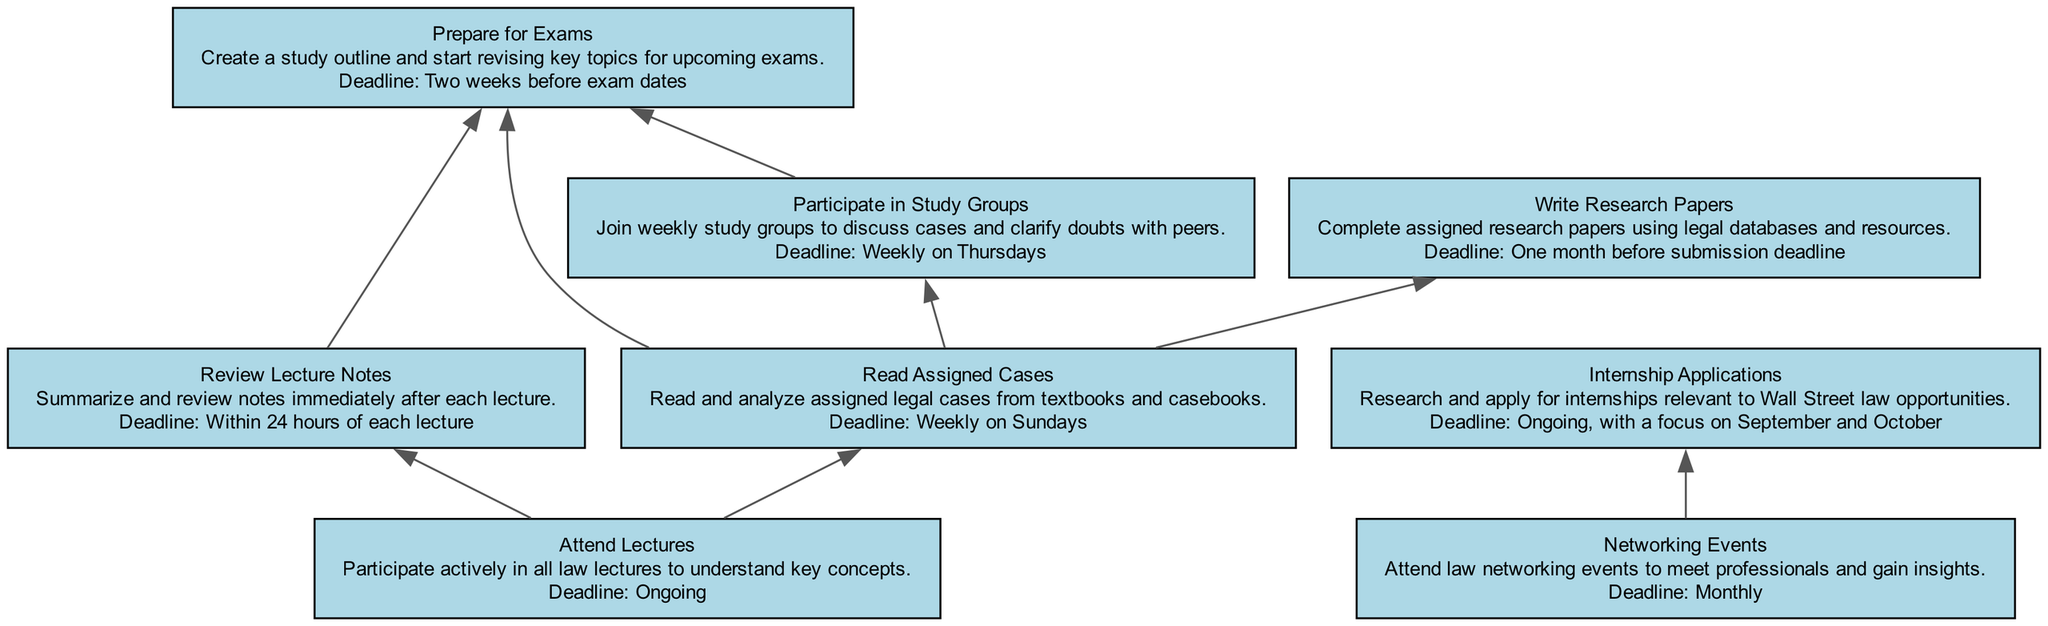What task is ongoing? The task that is ongoing is "Internship Applications" as indicated in the diagram. It is connected to networking events, reflecting its continuous nature in relation to other tasks.
Answer: Internship Applications How many nodes are present in the diagram? To find the total number of nodes, we count the tasks listed: Attend Lectures, Review Lecture Notes, Read Assigned Cases, Prepare for Exams, Participate in Study Groups, Write Research Papers, Internship Applications, and Networking Events. This totals up to 8 nodes.
Answer: 8 Which task needs to be completed within 24 hours? The task that needs to be completed within 24 hours is "Review Lecture Notes" as described in the diagram's details. It is specifically time-sensitive, asking for immediate action after lectures.
Answer: Review Lecture Notes Which task connects both the "Read Assigned Cases" and "Prepare for Exams"? The task that connects "Read Assigned Cases" to "Prepare for Exams" is "Participate in Study Groups." The diagram shows that insights drawn from study groups help in preparing for exams, creating a flow from assigned reading to exam preparation.
Answer: Participate in Study Groups How often are networking events scheduled? Networking events are scheduled monthly, as indicated in the task's deadline section on the diagram. This indicates regular participation opportunities to build professional connections.
Answer: Monthly What is the deadline for writing research papers? The deadline for writing research papers is specified as "One month before submission deadline" in the diagram. This means students need to allocate sufficient time to research and write prior to due dates.
Answer: One month before submission deadline What is the relationship between "Attend Lectures" and "Review Lecture Notes"? The relationship is that "Review Lecture Notes" directly follows "Attend Lectures." This signifies that active participation in lectures is essential for timely review of the notes taken during those lectures.
Answer: Directly follows Which task has a deadline of "Weekly on Sundays"? The task with a deadline of "Weekly on Sundays" is "Read Assigned Cases," highlighting its recurring nature in the study schedule as designated in the diagram.
Answer: Read Assigned Cases 